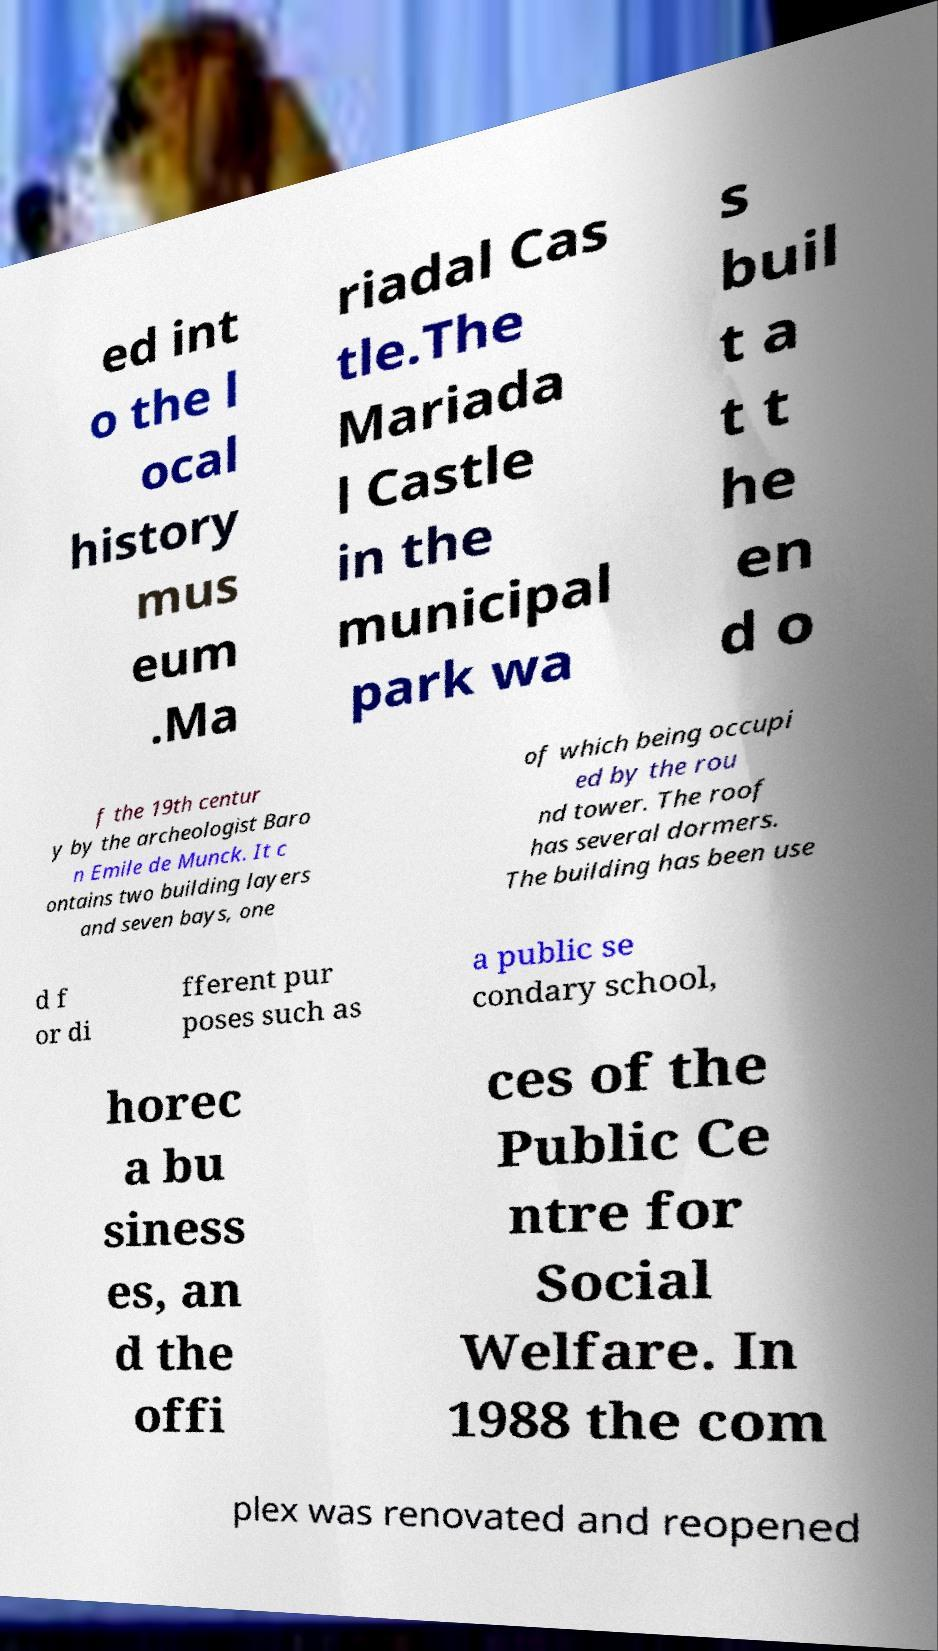Can you accurately transcribe the text from the provided image for me? ed int o the l ocal history mus eum .Ma riadal Cas tle.The Mariada l Castle in the municipal park wa s buil t a t t he en d o f the 19th centur y by the archeologist Baro n Emile de Munck. It c ontains two building layers and seven bays, one of which being occupi ed by the rou nd tower. The roof has several dormers. The building has been use d f or di fferent pur poses such as a public se condary school, horec a bu siness es, an d the offi ces of the Public Ce ntre for Social Welfare. In 1988 the com plex was renovated and reopened 